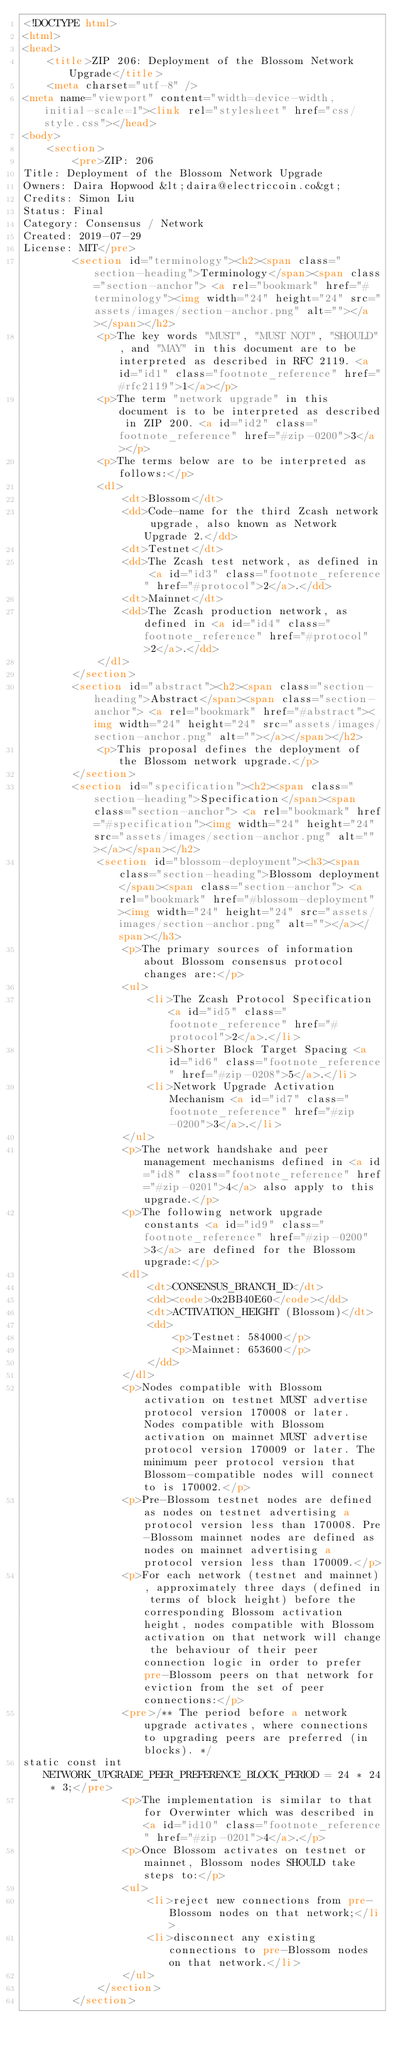<code> <loc_0><loc_0><loc_500><loc_500><_HTML_><!DOCTYPE html>
<html>
<head>
    <title>ZIP 206: Deployment of the Blossom Network Upgrade</title>
    <meta charset="utf-8" />
<meta name="viewport" content="width=device-width, initial-scale=1"><link rel="stylesheet" href="css/style.css"></head>
<body>
    <section>
        <pre>ZIP: 206
Title: Deployment of the Blossom Network Upgrade
Owners: Daira Hopwood &lt;daira@electriccoin.co&gt;
Credits: Simon Liu
Status: Final
Category: Consensus / Network
Created: 2019-07-29
License: MIT</pre>
        <section id="terminology"><h2><span class="section-heading">Terminology</span><span class="section-anchor"> <a rel="bookmark" href="#terminology"><img width="24" height="24" src="assets/images/section-anchor.png" alt=""></a></span></h2>
            <p>The key words "MUST", "MUST NOT", "SHOULD", and "MAY" in this document are to be interpreted as described in RFC 2119. <a id="id1" class="footnote_reference" href="#rfc2119">1</a></p>
            <p>The term "network upgrade" in this document is to be interpreted as described in ZIP 200. <a id="id2" class="footnote_reference" href="#zip-0200">3</a></p>
            <p>The terms below are to be interpreted as follows:</p>
            <dl>
                <dt>Blossom</dt>
                <dd>Code-name for the third Zcash network upgrade, also known as Network Upgrade 2.</dd>
                <dt>Testnet</dt>
                <dd>The Zcash test network, as defined in <a id="id3" class="footnote_reference" href="#protocol">2</a>.</dd>
                <dt>Mainnet</dt>
                <dd>The Zcash production network, as defined in <a id="id4" class="footnote_reference" href="#protocol">2</a>.</dd>
            </dl>
        </section>
        <section id="abstract"><h2><span class="section-heading">Abstract</span><span class="section-anchor"> <a rel="bookmark" href="#abstract"><img width="24" height="24" src="assets/images/section-anchor.png" alt=""></a></span></h2>
            <p>This proposal defines the deployment of the Blossom network upgrade.</p>
        </section>
        <section id="specification"><h2><span class="section-heading">Specification</span><span class="section-anchor"> <a rel="bookmark" href="#specification"><img width="24" height="24" src="assets/images/section-anchor.png" alt=""></a></span></h2>
            <section id="blossom-deployment"><h3><span class="section-heading">Blossom deployment</span><span class="section-anchor"> <a rel="bookmark" href="#blossom-deployment"><img width="24" height="24" src="assets/images/section-anchor.png" alt=""></a></span></h3>
                <p>The primary sources of information about Blossom consensus protocol changes are:</p>
                <ul>
                    <li>The Zcash Protocol Specification <a id="id5" class="footnote_reference" href="#protocol">2</a>.</li>
                    <li>Shorter Block Target Spacing <a id="id6" class="footnote_reference" href="#zip-0208">5</a>.</li>
                    <li>Network Upgrade Activation Mechanism <a id="id7" class="footnote_reference" href="#zip-0200">3</a>.</li>
                </ul>
                <p>The network handshake and peer management mechanisms defined in <a id="id8" class="footnote_reference" href="#zip-0201">4</a> also apply to this upgrade.</p>
                <p>The following network upgrade constants <a id="id9" class="footnote_reference" href="#zip-0200">3</a> are defined for the Blossom upgrade:</p>
                <dl>
                    <dt>CONSENSUS_BRANCH_ID</dt>
                    <dd><code>0x2BB40E60</code></dd>
                    <dt>ACTIVATION_HEIGHT (Blossom)</dt>
                    <dd>
                        <p>Testnet: 584000</p>
                        <p>Mainnet: 653600</p>
                    </dd>
                </dl>
                <p>Nodes compatible with Blossom activation on testnet MUST advertise protocol version 170008 or later. Nodes compatible with Blossom activation on mainnet MUST advertise protocol version 170009 or later. The minimum peer protocol version that Blossom-compatible nodes will connect to is 170002.</p>
                <p>Pre-Blossom testnet nodes are defined as nodes on testnet advertising a protocol version less than 170008. Pre-Blossom mainnet nodes are defined as nodes on mainnet advertising a protocol version less than 170009.</p>
                <p>For each network (testnet and mainnet), approximately three days (defined in terms of block height) before the corresponding Blossom activation height, nodes compatible with Blossom activation on that network will change the behaviour of their peer connection logic in order to prefer pre-Blossom peers on that network for eviction from the set of peer connections:</p>
                <pre>/** The period before a network upgrade activates, where connections to upgrading peers are preferred (in blocks). */
static const int NETWORK_UPGRADE_PEER_PREFERENCE_BLOCK_PERIOD = 24 * 24 * 3;</pre>
                <p>The implementation is similar to that for Overwinter which was described in <a id="id10" class="footnote_reference" href="#zip-0201">4</a>.</p>
                <p>Once Blossom activates on testnet or mainnet, Blossom nodes SHOULD take steps to:</p>
                <ul>
                    <li>reject new connections from pre-Blossom nodes on that network;</li>
                    <li>disconnect any existing connections to pre-Blossom nodes on that network.</li>
                </ul>
            </section>
        </section></code> 